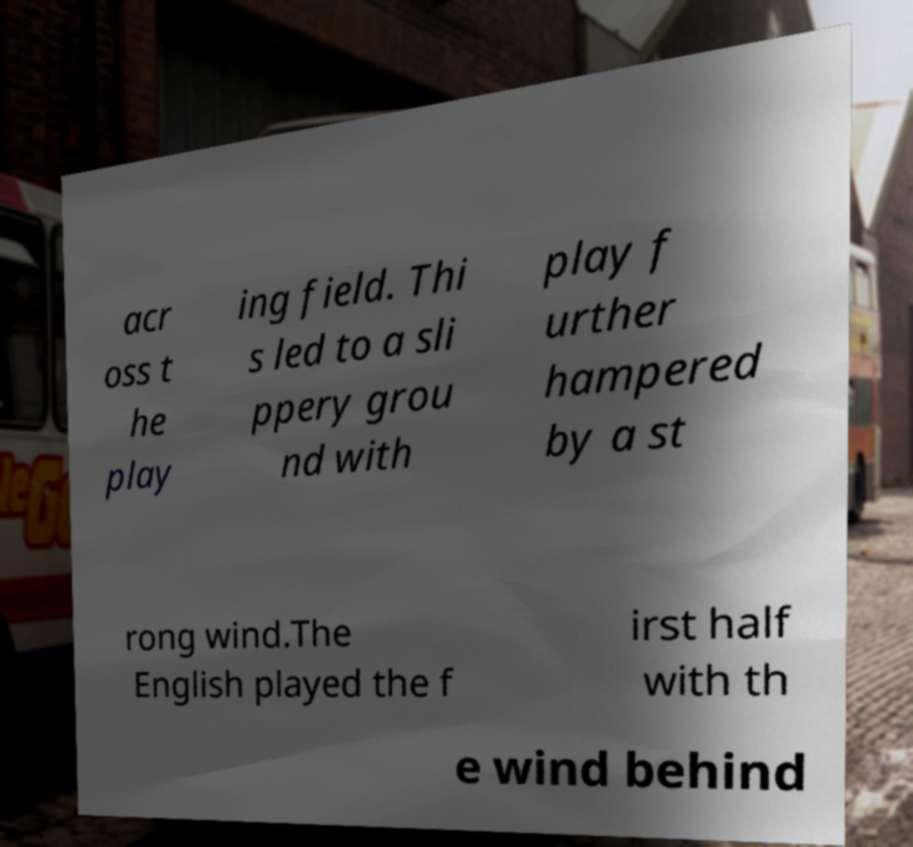What messages or text are displayed in this image? I need them in a readable, typed format. acr oss t he play ing field. Thi s led to a sli ppery grou nd with play f urther hampered by a st rong wind.The English played the f irst half with th e wind behind 